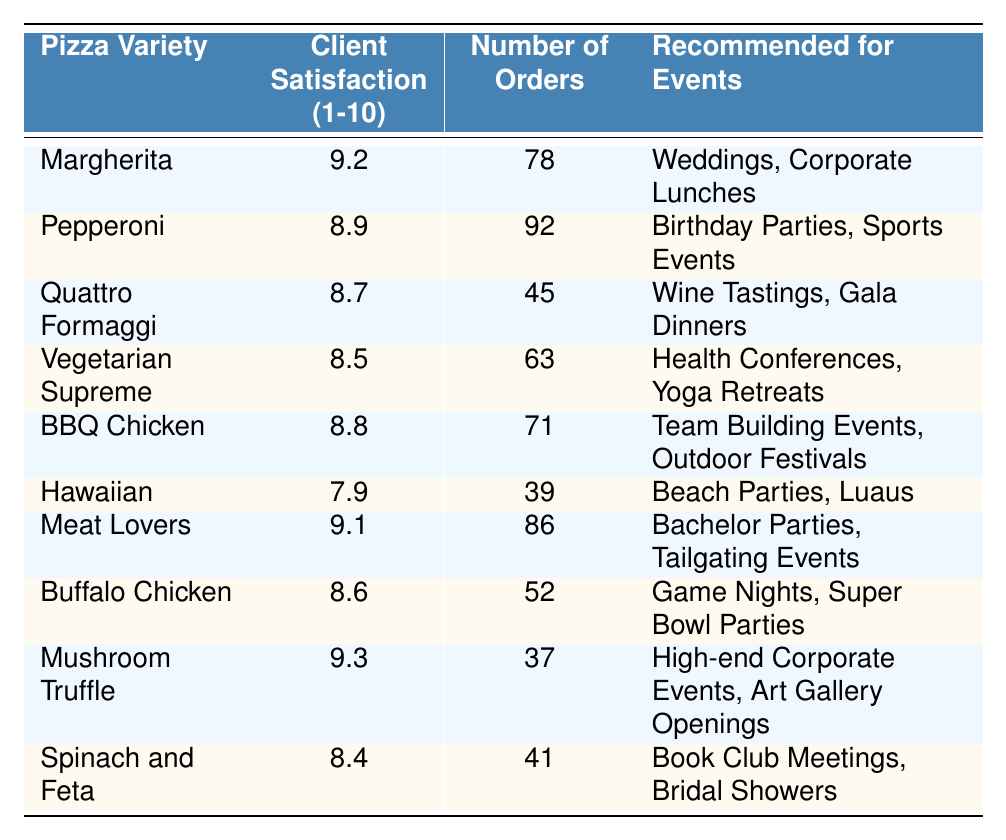What is the highest client satisfaction rating among the pizza varieties? By reviewing the Client Satisfaction Rating column, we find that Mushroom Truffle has the highest rating at 9.3.
Answer: 9.3 Which pizza variety is recommended for Health Conferences? The table indicates that the Vegetarian Supreme is recommended for Health Conferences.
Answer: Vegetarian Supreme How many total orders were placed for Pepperoni and BBQ Chicken combined? The number of orders for Pepperoni is 92 and for BBQ Chicken is 71. Adding these gives us 92 + 71 = 163.
Answer: 163 Is the Hawaiian pizza variety more recommended for Luaus than Corporate Lunches? The Hawaiian pizza is specifically recommended for Luaus, while Margherita is recommended for Corporate Lunches. Comparatively, Hawaiian is only linked with Luaus.
Answer: Yes What is the average client satisfaction rating for the top three rated pizza varieties? The top three pizzas by rating are Mushroom Truffle (9.3), Margherita (9.2), and Meat Lovers (9.1). The sum of their ratings is 9.3 + 9.2 + 9.1 = 27.6, and dividing by 3 gives us an average of 27.6 / 3 = 9.2.
Answer: 9.2 Which pizza variety has the lowest client satisfaction rating and what is that rating? Looking at the table, the Hawaiian pizza has the lowest satisfaction rating at 7.9.
Answer: 7.9 List the recommended events for the Mushroom Truffle pizza variety. The Mushroom Truffle pizza is recommended for High-end Corporate Events and Art Gallery Openings, as detailed in the table.
Answer: High-end Corporate Events, Art Gallery Openings How many more orders were made for the Pepperoni than the Hawaiian pizza? The Pepperoni had 92 orders and the Hawaiian had 39 orders. Subtracting these gives 92 - 39 = 53 more orders for Pepperoni.
Answer: 53 What percentage of total orders does the BBQ Chicken represent? Total orders across all varieties are 78 + 92 + 45 + 63 + 71 + 39 + 86 + 52 + 37 + 41 = 602. BBQ Chicken had 71 orders, which is (71 / 602) * 100 = 11.79%.
Answer: 11.79% Which two pizza varieties are recommended for "Game Nights"? According to the table, Buffalo Chicken is recommended for Game Nights; however, no other variety is mentioned for this event.
Answer: Buffalo Chicken only 